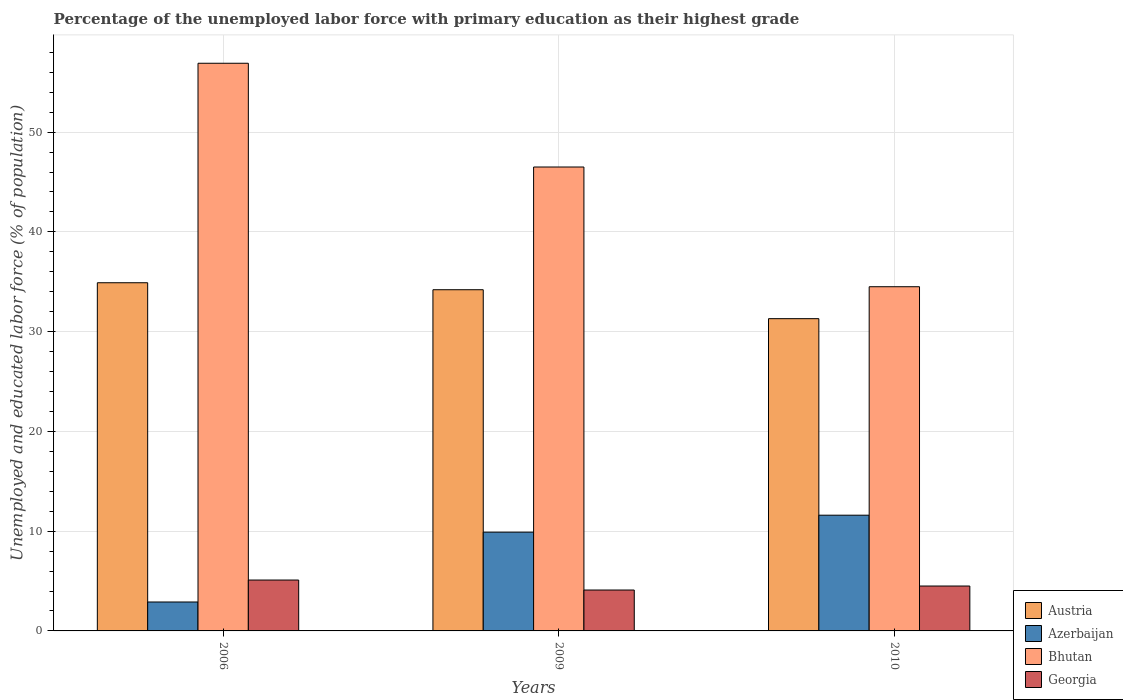How many bars are there on the 3rd tick from the left?
Keep it short and to the point. 4. In how many cases, is the number of bars for a given year not equal to the number of legend labels?
Offer a terse response. 0. What is the percentage of the unemployed labor force with primary education in Bhutan in 2006?
Provide a short and direct response. 56.9. Across all years, what is the maximum percentage of the unemployed labor force with primary education in Austria?
Your answer should be very brief. 34.9. Across all years, what is the minimum percentage of the unemployed labor force with primary education in Azerbaijan?
Provide a short and direct response. 2.9. In which year was the percentage of the unemployed labor force with primary education in Austria maximum?
Offer a very short reply. 2006. In which year was the percentage of the unemployed labor force with primary education in Austria minimum?
Provide a short and direct response. 2010. What is the total percentage of the unemployed labor force with primary education in Austria in the graph?
Your answer should be compact. 100.4. What is the difference between the percentage of the unemployed labor force with primary education in Azerbaijan in 2006 and that in 2010?
Provide a succinct answer. -8.7. What is the difference between the percentage of the unemployed labor force with primary education in Austria in 2009 and the percentage of the unemployed labor force with primary education in Georgia in 2006?
Keep it short and to the point. 29.1. What is the average percentage of the unemployed labor force with primary education in Georgia per year?
Your answer should be compact. 4.57. In the year 2006, what is the difference between the percentage of the unemployed labor force with primary education in Bhutan and percentage of the unemployed labor force with primary education in Austria?
Make the answer very short. 22. What is the ratio of the percentage of the unemployed labor force with primary education in Azerbaijan in 2006 to that in 2010?
Give a very brief answer. 0.25. Is the percentage of the unemployed labor force with primary education in Austria in 2006 less than that in 2010?
Ensure brevity in your answer.  No. What is the difference between the highest and the second highest percentage of the unemployed labor force with primary education in Azerbaijan?
Give a very brief answer. 1.7. What is the difference between the highest and the lowest percentage of the unemployed labor force with primary education in Austria?
Make the answer very short. 3.6. What does the 2nd bar from the left in 2010 represents?
Make the answer very short. Azerbaijan. What does the 2nd bar from the right in 2006 represents?
Offer a terse response. Bhutan. Is it the case that in every year, the sum of the percentage of the unemployed labor force with primary education in Austria and percentage of the unemployed labor force with primary education in Georgia is greater than the percentage of the unemployed labor force with primary education in Azerbaijan?
Ensure brevity in your answer.  Yes. How many bars are there?
Give a very brief answer. 12. What is the difference between two consecutive major ticks on the Y-axis?
Make the answer very short. 10. Are the values on the major ticks of Y-axis written in scientific E-notation?
Offer a terse response. No. How many legend labels are there?
Ensure brevity in your answer.  4. What is the title of the graph?
Provide a succinct answer. Percentage of the unemployed labor force with primary education as their highest grade. What is the label or title of the Y-axis?
Offer a very short reply. Unemployed and educated labor force (% of population). What is the Unemployed and educated labor force (% of population) of Austria in 2006?
Your response must be concise. 34.9. What is the Unemployed and educated labor force (% of population) in Azerbaijan in 2006?
Your answer should be compact. 2.9. What is the Unemployed and educated labor force (% of population) of Bhutan in 2006?
Your response must be concise. 56.9. What is the Unemployed and educated labor force (% of population) of Georgia in 2006?
Provide a short and direct response. 5.1. What is the Unemployed and educated labor force (% of population) in Austria in 2009?
Make the answer very short. 34.2. What is the Unemployed and educated labor force (% of population) in Azerbaijan in 2009?
Give a very brief answer. 9.9. What is the Unemployed and educated labor force (% of population) in Bhutan in 2009?
Your response must be concise. 46.5. What is the Unemployed and educated labor force (% of population) of Georgia in 2009?
Make the answer very short. 4.1. What is the Unemployed and educated labor force (% of population) in Austria in 2010?
Offer a very short reply. 31.3. What is the Unemployed and educated labor force (% of population) in Azerbaijan in 2010?
Your answer should be very brief. 11.6. What is the Unemployed and educated labor force (% of population) in Bhutan in 2010?
Provide a succinct answer. 34.5. What is the Unemployed and educated labor force (% of population) of Georgia in 2010?
Keep it short and to the point. 4.5. Across all years, what is the maximum Unemployed and educated labor force (% of population) in Austria?
Give a very brief answer. 34.9. Across all years, what is the maximum Unemployed and educated labor force (% of population) of Azerbaijan?
Your answer should be very brief. 11.6. Across all years, what is the maximum Unemployed and educated labor force (% of population) in Bhutan?
Provide a short and direct response. 56.9. Across all years, what is the maximum Unemployed and educated labor force (% of population) of Georgia?
Offer a very short reply. 5.1. Across all years, what is the minimum Unemployed and educated labor force (% of population) of Austria?
Your response must be concise. 31.3. Across all years, what is the minimum Unemployed and educated labor force (% of population) in Azerbaijan?
Offer a very short reply. 2.9. Across all years, what is the minimum Unemployed and educated labor force (% of population) of Bhutan?
Your answer should be very brief. 34.5. Across all years, what is the minimum Unemployed and educated labor force (% of population) in Georgia?
Offer a terse response. 4.1. What is the total Unemployed and educated labor force (% of population) in Austria in the graph?
Ensure brevity in your answer.  100.4. What is the total Unemployed and educated labor force (% of population) of Azerbaijan in the graph?
Ensure brevity in your answer.  24.4. What is the total Unemployed and educated labor force (% of population) in Bhutan in the graph?
Keep it short and to the point. 137.9. What is the difference between the Unemployed and educated labor force (% of population) of Azerbaijan in 2006 and that in 2009?
Offer a very short reply. -7. What is the difference between the Unemployed and educated labor force (% of population) in Austria in 2006 and that in 2010?
Offer a terse response. 3.6. What is the difference between the Unemployed and educated labor force (% of population) of Bhutan in 2006 and that in 2010?
Give a very brief answer. 22.4. What is the difference between the Unemployed and educated labor force (% of population) of Austria in 2009 and that in 2010?
Ensure brevity in your answer.  2.9. What is the difference between the Unemployed and educated labor force (% of population) in Bhutan in 2009 and that in 2010?
Provide a short and direct response. 12. What is the difference between the Unemployed and educated labor force (% of population) of Georgia in 2009 and that in 2010?
Offer a very short reply. -0.4. What is the difference between the Unemployed and educated labor force (% of population) in Austria in 2006 and the Unemployed and educated labor force (% of population) in Azerbaijan in 2009?
Your answer should be compact. 25. What is the difference between the Unemployed and educated labor force (% of population) in Austria in 2006 and the Unemployed and educated labor force (% of population) in Georgia in 2009?
Your answer should be very brief. 30.8. What is the difference between the Unemployed and educated labor force (% of population) in Azerbaijan in 2006 and the Unemployed and educated labor force (% of population) in Bhutan in 2009?
Ensure brevity in your answer.  -43.6. What is the difference between the Unemployed and educated labor force (% of population) in Azerbaijan in 2006 and the Unemployed and educated labor force (% of population) in Georgia in 2009?
Make the answer very short. -1.2. What is the difference between the Unemployed and educated labor force (% of population) in Bhutan in 2006 and the Unemployed and educated labor force (% of population) in Georgia in 2009?
Your response must be concise. 52.8. What is the difference between the Unemployed and educated labor force (% of population) in Austria in 2006 and the Unemployed and educated labor force (% of population) in Azerbaijan in 2010?
Provide a succinct answer. 23.3. What is the difference between the Unemployed and educated labor force (% of population) in Austria in 2006 and the Unemployed and educated labor force (% of population) in Georgia in 2010?
Ensure brevity in your answer.  30.4. What is the difference between the Unemployed and educated labor force (% of population) in Azerbaijan in 2006 and the Unemployed and educated labor force (% of population) in Bhutan in 2010?
Your answer should be compact. -31.6. What is the difference between the Unemployed and educated labor force (% of population) of Azerbaijan in 2006 and the Unemployed and educated labor force (% of population) of Georgia in 2010?
Provide a succinct answer. -1.6. What is the difference between the Unemployed and educated labor force (% of population) in Bhutan in 2006 and the Unemployed and educated labor force (% of population) in Georgia in 2010?
Give a very brief answer. 52.4. What is the difference between the Unemployed and educated labor force (% of population) in Austria in 2009 and the Unemployed and educated labor force (% of population) in Azerbaijan in 2010?
Your answer should be compact. 22.6. What is the difference between the Unemployed and educated labor force (% of population) of Austria in 2009 and the Unemployed and educated labor force (% of population) of Georgia in 2010?
Provide a short and direct response. 29.7. What is the difference between the Unemployed and educated labor force (% of population) of Azerbaijan in 2009 and the Unemployed and educated labor force (% of population) of Bhutan in 2010?
Offer a very short reply. -24.6. What is the difference between the Unemployed and educated labor force (% of population) of Bhutan in 2009 and the Unemployed and educated labor force (% of population) of Georgia in 2010?
Keep it short and to the point. 42. What is the average Unemployed and educated labor force (% of population) in Austria per year?
Ensure brevity in your answer.  33.47. What is the average Unemployed and educated labor force (% of population) of Azerbaijan per year?
Provide a short and direct response. 8.13. What is the average Unemployed and educated labor force (% of population) in Bhutan per year?
Make the answer very short. 45.97. What is the average Unemployed and educated labor force (% of population) of Georgia per year?
Your response must be concise. 4.57. In the year 2006, what is the difference between the Unemployed and educated labor force (% of population) in Austria and Unemployed and educated labor force (% of population) in Georgia?
Offer a terse response. 29.8. In the year 2006, what is the difference between the Unemployed and educated labor force (% of population) of Azerbaijan and Unemployed and educated labor force (% of population) of Bhutan?
Give a very brief answer. -54. In the year 2006, what is the difference between the Unemployed and educated labor force (% of population) in Bhutan and Unemployed and educated labor force (% of population) in Georgia?
Your answer should be very brief. 51.8. In the year 2009, what is the difference between the Unemployed and educated labor force (% of population) of Austria and Unemployed and educated labor force (% of population) of Azerbaijan?
Offer a terse response. 24.3. In the year 2009, what is the difference between the Unemployed and educated labor force (% of population) of Austria and Unemployed and educated labor force (% of population) of Bhutan?
Ensure brevity in your answer.  -12.3. In the year 2009, what is the difference between the Unemployed and educated labor force (% of population) in Austria and Unemployed and educated labor force (% of population) in Georgia?
Give a very brief answer. 30.1. In the year 2009, what is the difference between the Unemployed and educated labor force (% of population) in Azerbaijan and Unemployed and educated labor force (% of population) in Bhutan?
Give a very brief answer. -36.6. In the year 2009, what is the difference between the Unemployed and educated labor force (% of population) of Bhutan and Unemployed and educated labor force (% of population) of Georgia?
Offer a terse response. 42.4. In the year 2010, what is the difference between the Unemployed and educated labor force (% of population) of Austria and Unemployed and educated labor force (% of population) of Azerbaijan?
Provide a succinct answer. 19.7. In the year 2010, what is the difference between the Unemployed and educated labor force (% of population) in Austria and Unemployed and educated labor force (% of population) in Bhutan?
Keep it short and to the point. -3.2. In the year 2010, what is the difference between the Unemployed and educated labor force (% of population) of Austria and Unemployed and educated labor force (% of population) of Georgia?
Make the answer very short. 26.8. In the year 2010, what is the difference between the Unemployed and educated labor force (% of population) of Azerbaijan and Unemployed and educated labor force (% of population) of Bhutan?
Your response must be concise. -22.9. In the year 2010, what is the difference between the Unemployed and educated labor force (% of population) in Azerbaijan and Unemployed and educated labor force (% of population) in Georgia?
Ensure brevity in your answer.  7.1. In the year 2010, what is the difference between the Unemployed and educated labor force (% of population) in Bhutan and Unemployed and educated labor force (% of population) in Georgia?
Make the answer very short. 30. What is the ratio of the Unemployed and educated labor force (% of population) of Austria in 2006 to that in 2009?
Provide a succinct answer. 1.02. What is the ratio of the Unemployed and educated labor force (% of population) of Azerbaijan in 2006 to that in 2009?
Provide a short and direct response. 0.29. What is the ratio of the Unemployed and educated labor force (% of population) in Bhutan in 2006 to that in 2009?
Keep it short and to the point. 1.22. What is the ratio of the Unemployed and educated labor force (% of population) in Georgia in 2006 to that in 2009?
Your response must be concise. 1.24. What is the ratio of the Unemployed and educated labor force (% of population) in Austria in 2006 to that in 2010?
Make the answer very short. 1.11. What is the ratio of the Unemployed and educated labor force (% of population) of Azerbaijan in 2006 to that in 2010?
Your response must be concise. 0.25. What is the ratio of the Unemployed and educated labor force (% of population) in Bhutan in 2006 to that in 2010?
Give a very brief answer. 1.65. What is the ratio of the Unemployed and educated labor force (% of population) of Georgia in 2006 to that in 2010?
Give a very brief answer. 1.13. What is the ratio of the Unemployed and educated labor force (% of population) in Austria in 2009 to that in 2010?
Offer a terse response. 1.09. What is the ratio of the Unemployed and educated labor force (% of population) in Azerbaijan in 2009 to that in 2010?
Provide a succinct answer. 0.85. What is the ratio of the Unemployed and educated labor force (% of population) of Bhutan in 2009 to that in 2010?
Ensure brevity in your answer.  1.35. What is the ratio of the Unemployed and educated labor force (% of population) of Georgia in 2009 to that in 2010?
Keep it short and to the point. 0.91. What is the difference between the highest and the second highest Unemployed and educated labor force (% of population) of Austria?
Keep it short and to the point. 0.7. What is the difference between the highest and the second highest Unemployed and educated labor force (% of population) of Azerbaijan?
Offer a terse response. 1.7. What is the difference between the highest and the second highest Unemployed and educated labor force (% of population) of Bhutan?
Your answer should be very brief. 10.4. What is the difference between the highest and the lowest Unemployed and educated labor force (% of population) in Austria?
Your response must be concise. 3.6. What is the difference between the highest and the lowest Unemployed and educated labor force (% of population) in Bhutan?
Ensure brevity in your answer.  22.4. 